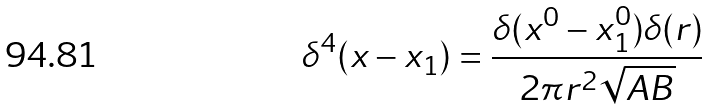<formula> <loc_0><loc_0><loc_500><loc_500>\delta ^ { 4 } ( x - x _ { 1 } ) = \frac { \delta ( x ^ { 0 } - x _ { 1 } ^ { 0 } ) \delta ( r ) } { 2 \pi r ^ { 2 } \sqrt { A B } }</formula> 